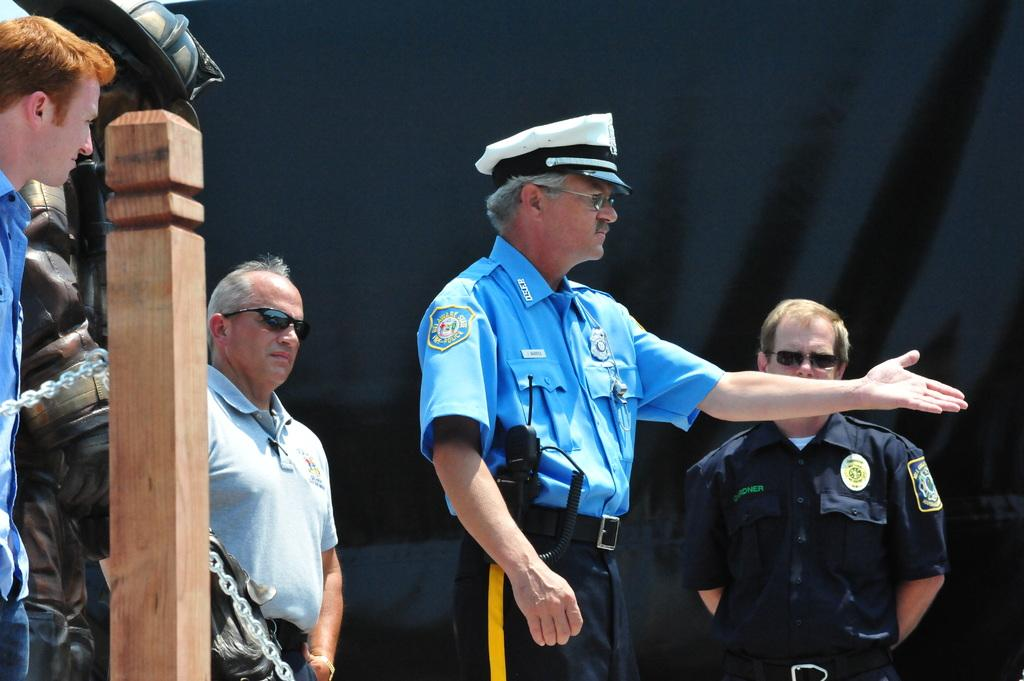What can be seen in the image involving people? There are persons standing in the image. What object is located in the front of the image? There is a wooden pole in the front of the image. What type of covering is present in the background of the image? There is a curtain in the background of the image. What is the color of the curtain? The curtain is black in color. What type of crack can be seen on the glass in the image? There is no glass present in the image, so there cannot be any cracks on it. 